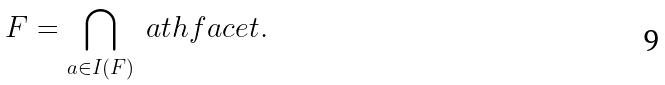Convert formula to latex. <formula><loc_0><loc_0><loc_500><loc_500>F = \bigcap _ { a \in I ( F ) } \ a t h f a c e t .</formula> 